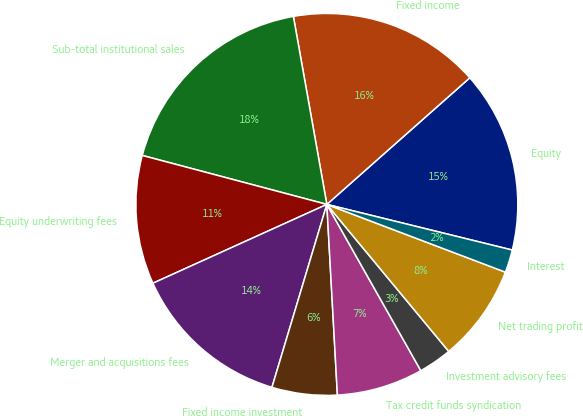Convert chart. <chart><loc_0><loc_0><loc_500><loc_500><pie_chart><fcel>Equity<fcel>Fixed income<fcel>Sub-total institutional sales<fcel>Equity underwriting fees<fcel>Merger and acquisitions fees<fcel>Fixed income investment<fcel>Tax credit funds syndication<fcel>Investment advisory fees<fcel>Net trading profit<fcel>Interest<nl><fcel>15.38%<fcel>16.27%<fcel>18.07%<fcel>10.9%<fcel>13.59%<fcel>5.52%<fcel>7.31%<fcel>2.83%<fcel>8.21%<fcel>1.93%<nl></chart> 